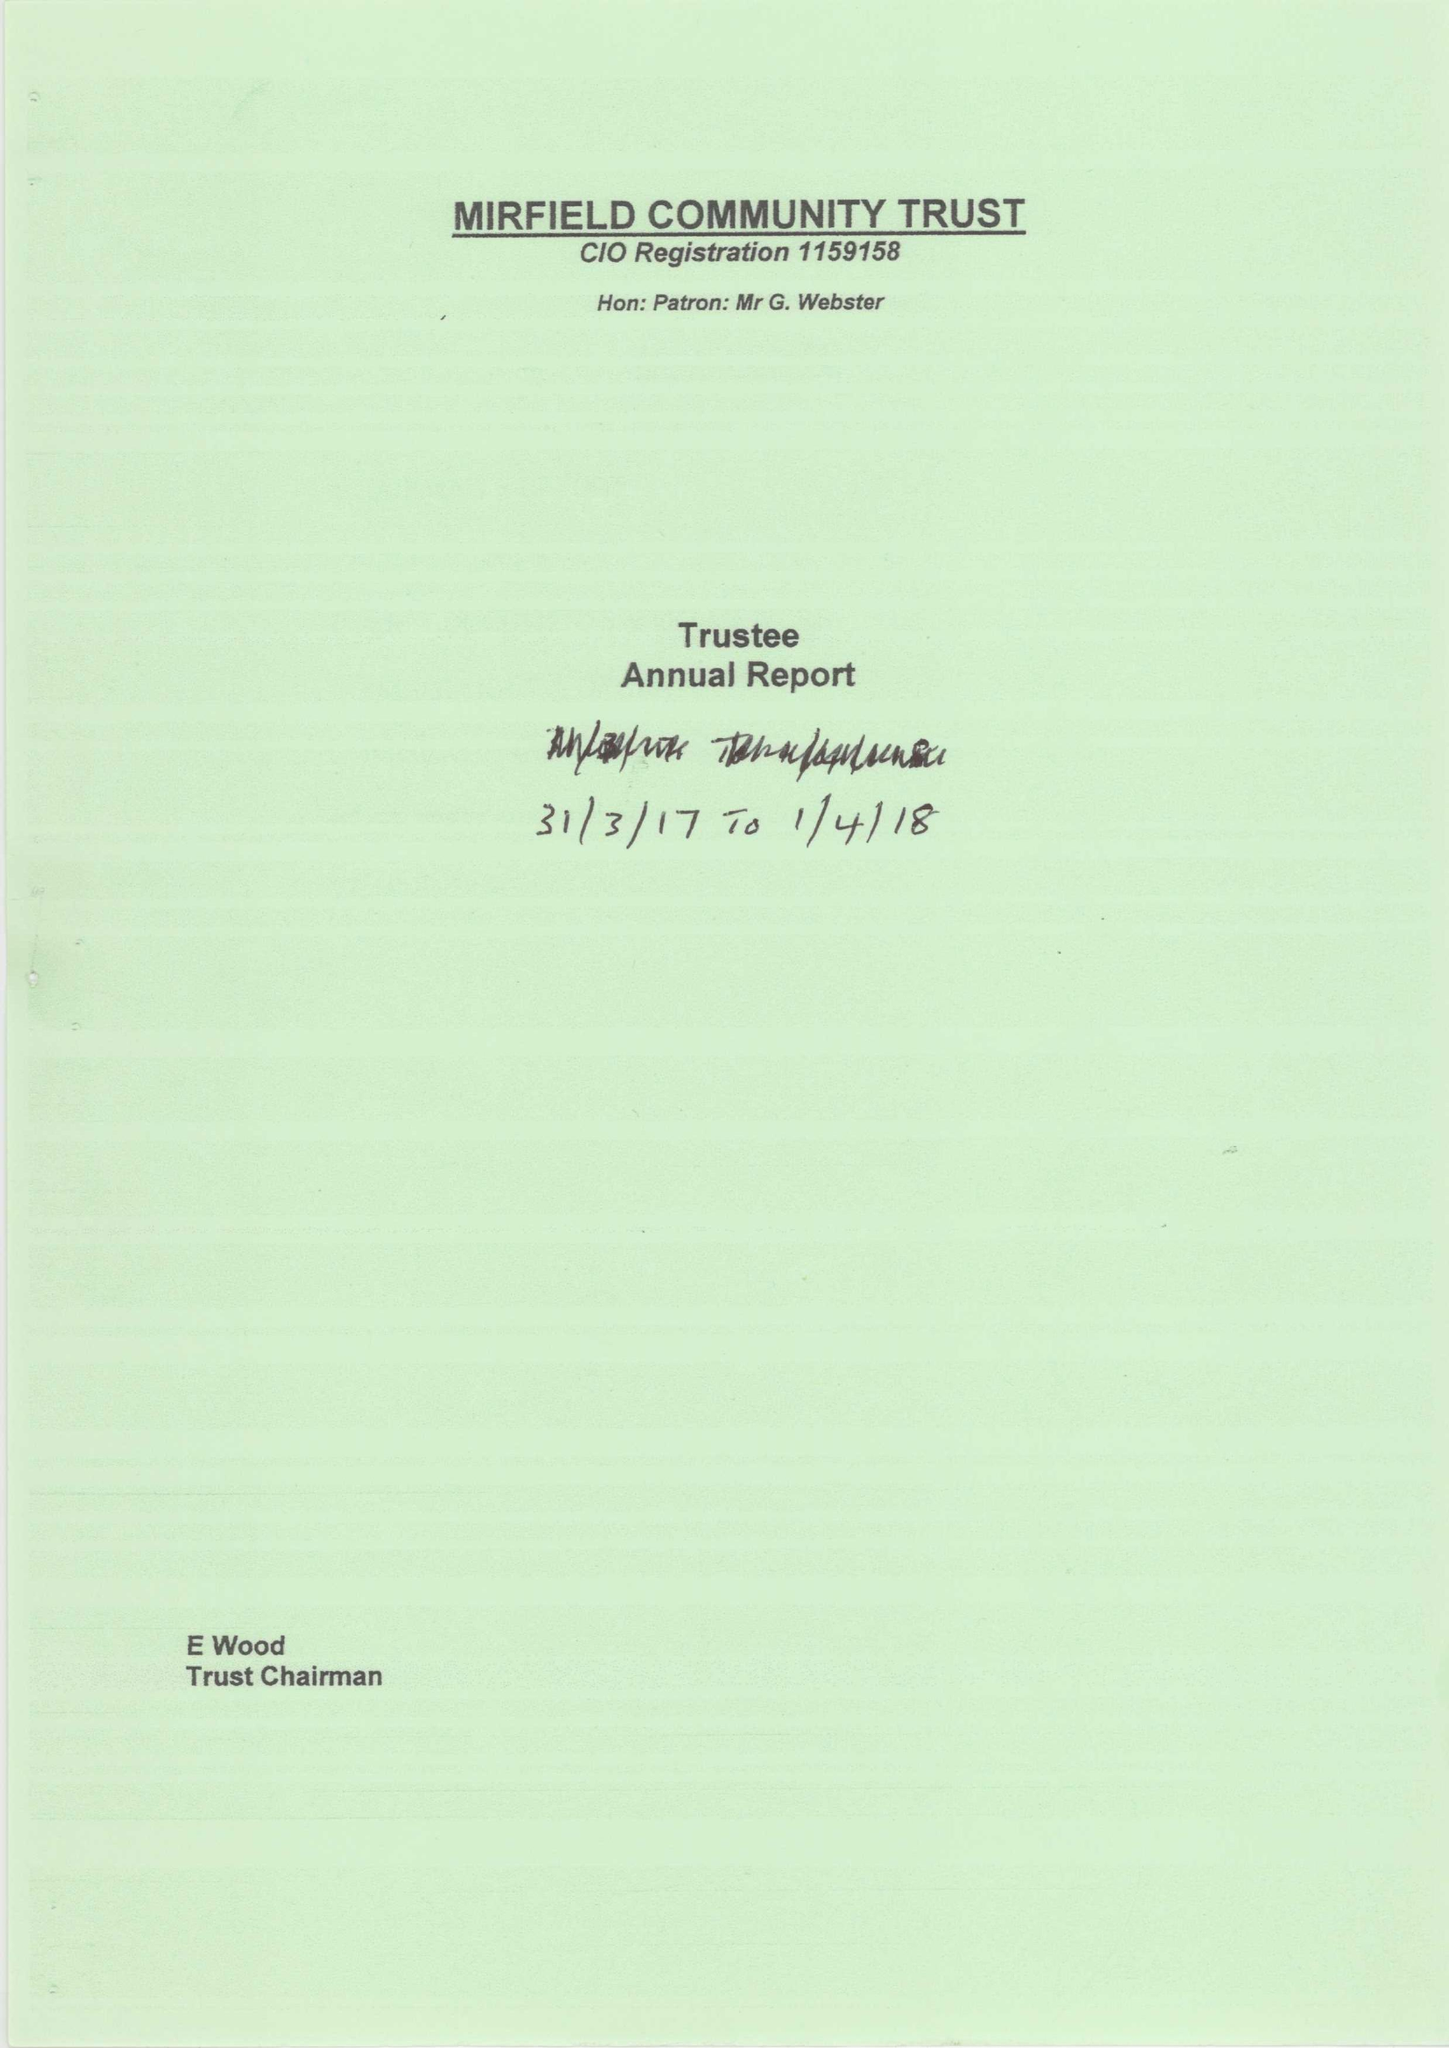What is the value for the address__post_town?
Answer the question using a single word or phrase. MIRFIELD 